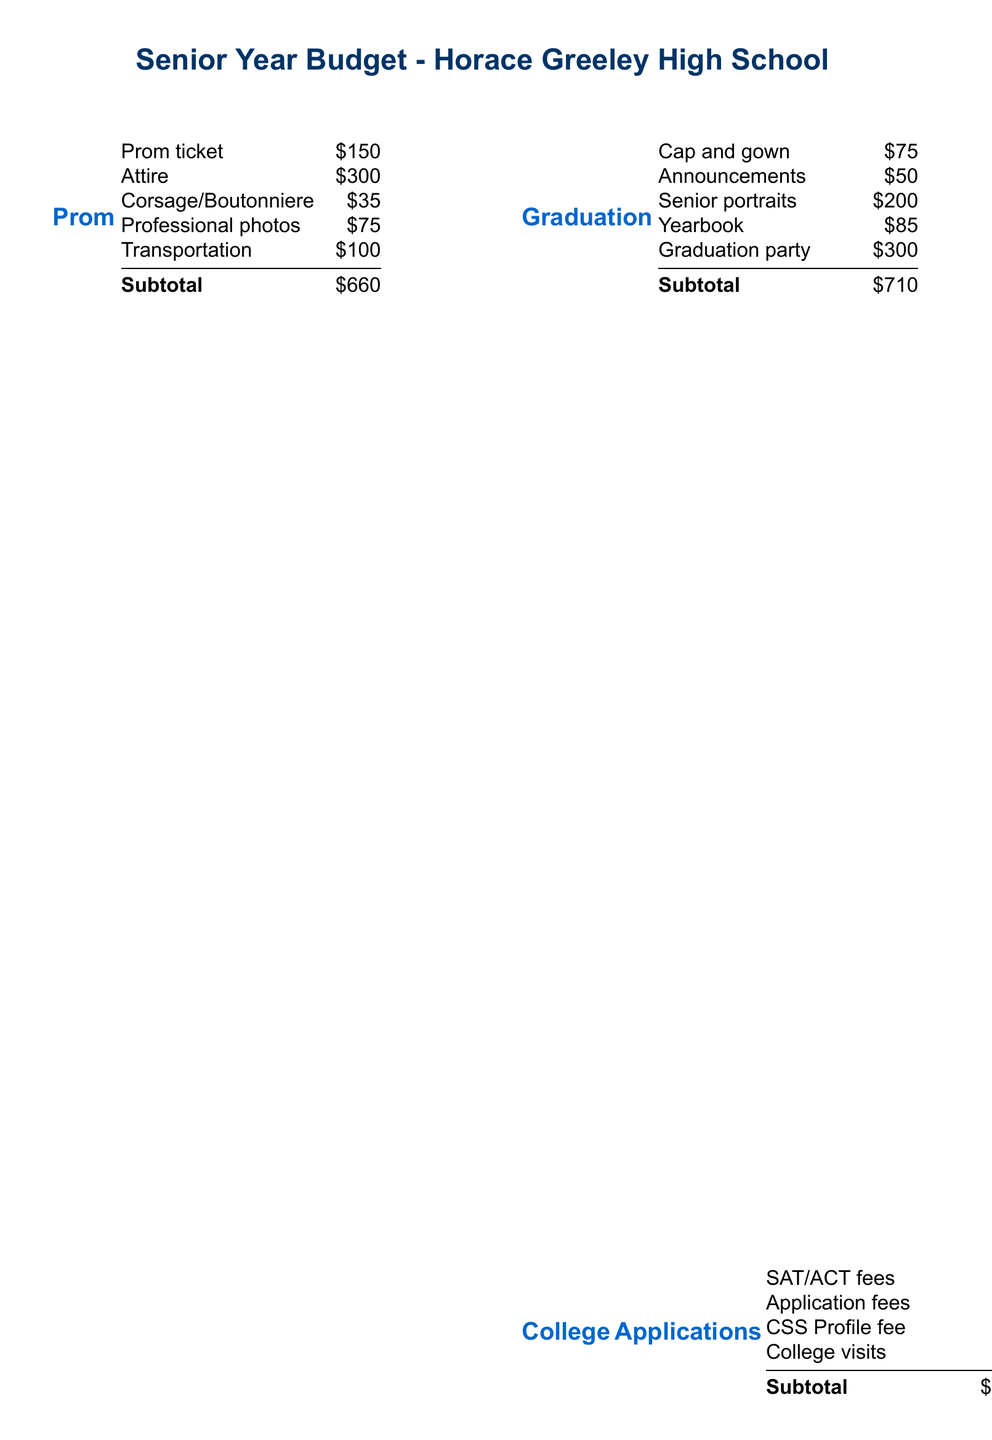What is the estimated cost of prom? The estimated cost of prom is the subtotal listed under the prom section, which includes various costs.
Answer: $660 What is the cost of senior portraits? The cost of senior portraits is provided in the graduation section of the budget.
Answer: $200 How much do college application fees total? College application fees are summed together in the college applications section.
Answer: $350 What is the total estimated cost for the senior year? The total estimated cost is listed at the end of the budget document.
Answer: $3,335 What is the cost of the senior class trip? The cost of the senior class trip is given in the senior activities section.
Answer: $250 How much is allocated for AP exam fees? The document specifies the AP exam fees in the miscellaneous category.
Answer: $190 What are the total estimated costs for graduation-related expenses? The total for graduation-related expenses is the subtotal from the graduation section.
Answer: $710 What is the cost of parking permits? The cost for parking permits is detailed in the miscellaneous expenses.
Answer: $75 What is the total for senior activities? The subtotal for senior activities is provided in the corresponding section of the budget.
Answer: $425 